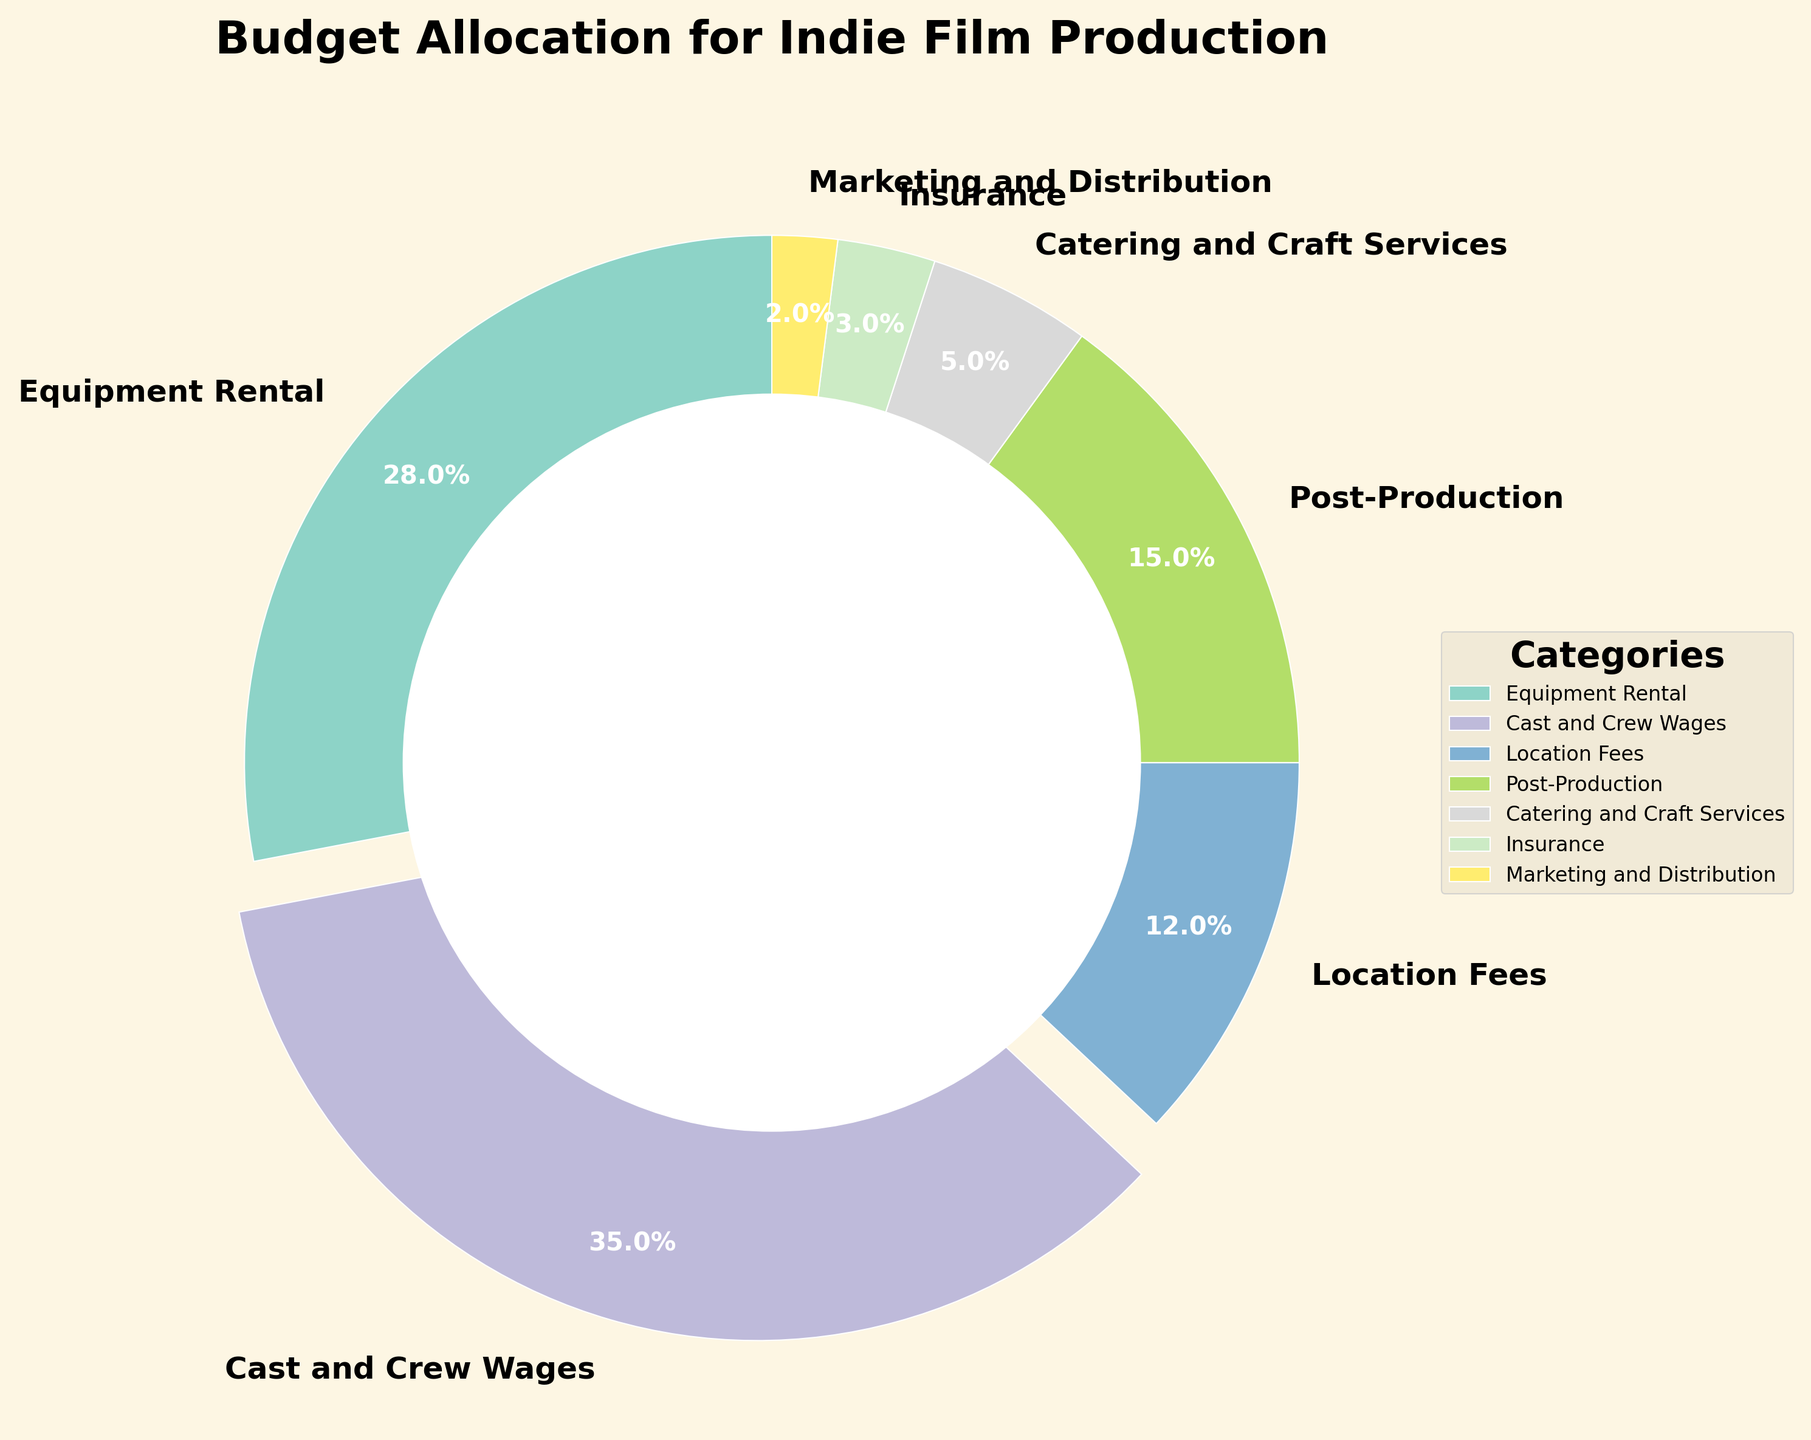Which category has the largest portion of the budget allocation? By observing the figure, the 'Cast and Crew Wages' category has the largest wedge, which also explodes out slightly. This indicates it has the highest percentage.
Answer: Cast and Crew Wages What is the combined percentage for Equipment Rental and Location Fees? From the figure, Equipment Rental takes up 28% and Location Fees 12%. Adding these together results in 28% + 12%.
Answer: 40% Is the percentage allocated to Post-Production more than the combined percentage for Catering and Craft Services and Insurance? According to the figure, Post-Production is 15%, while Catering and Craft Services is 5% and Insurance is 3%. Adding the latter two gives 5% + 3% = 8%. 15% is greater than 8%.
Answer: Yes Which category has the smallest allocation, and what is its percentage? From the figure, the smallest wedge is for 'Marketing and Distribution' which has the smallest percentage label.
Answer: Marketing and Distribution, 2% How much more is allocated to Cast and Crew Wages compared to Equipment Rental? The figure shows Cast and Crew Wages at 35% and Equipment Rental at 28%. The difference is calculated as 35% - 28%.
Answer: 7% What is the sum of percentages allocated to Post-Production, Insurance, and Marketing and Distribution? From the chart, Post-Production has 15%, Insurance 3%, and Marketing and Distribution 2%. Summing these gives 15% + 3% + 2%.
Answer: 20% Does Equipment Rental receive more allocation than Post-Production? The figure shows Equipment Rental at 28% and Post-Production at 15%. Comparing these indicates that Equipment Rental has a higher percentage.
Answer: Yes Which category, among Catering and Craft Services or Location Fees, has a higher allocation? The figure shows Catering and Craft Services at 5% and Location Fees at 12%. Thus, Location Fees have a higher allocation.
Answer: Location Fees What visual element highlights the largest section of the pie chart? The 'Cast and Crew Wages' section is highlighted as the largest section by being slightly exploded outwards.
Answer: Explosion of the wedge What is the ratio of the budget allocated to Cast and Crew Wages to Insurance? The chart shows Cast and Crew Wages at 35% and Insurance at 3%. The ratio is calculated as 35% / 3%.
Answer: 35:3 or approximately 11.7:1 